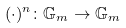<formula> <loc_0><loc_0><loc_500><loc_500>( \cdot ) ^ { n } \colon \mathbb { G } _ { m } \to \mathbb { G } _ { m }</formula> 